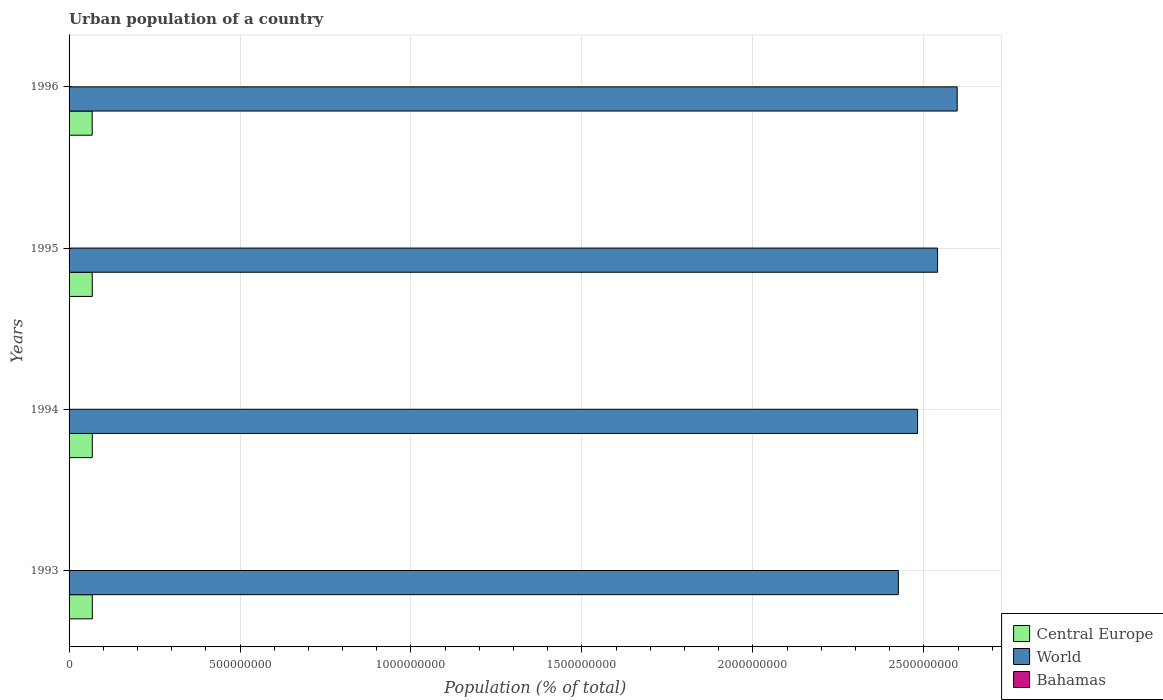How many different coloured bars are there?
Your response must be concise. 3. How many bars are there on the 4th tick from the top?
Provide a succinct answer. 3. How many bars are there on the 1st tick from the bottom?
Give a very brief answer. 3. In how many cases, is the number of bars for a given year not equal to the number of legend labels?
Your response must be concise. 0. What is the urban population in World in 1996?
Give a very brief answer. 2.60e+09. Across all years, what is the maximum urban population in World?
Ensure brevity in your answer.  2.60e+09. Across all years, what is the minimum urban population in Bahamas?
Give a very brief answer. 2.18e+05. In which year was the urban population in Central Europe maximum?
Keep it short and to the point. 1993. In which year was the urban population in Central Europe minimum?
Offer a terse response. 1996. What is the total urban population in World in the graph?
Your answer should be very brief. 1.00e+1. What is the difference between the urban population in Bahamas in 1994 and that in 1995?
Give a very brief answer. -4049. What is the difference between the urban population in Bahamas in 1993 and the urban population in Central Europe in 1995?
Offer a terse response. -6.76e+07. What is the average urban population in Central Europe per year?
Your answer should be very brief. 6.78e+07. In the year 1994, what is the difference between the urban population in World and urban population in Central Europe?
Offer a very short reply. 2.41e+09. What is the ratio of the urban population in Bahamas in 1993 to that in 1995?
Your answer should be compact. 0.96. Is the urban population in Central Europe in 1994 less than that in 1996?
Keep it short and to the point. No. Is the difference between the urban population in World in 1993 and 1994 greater than the difference between the urban population in Central Europe in 1993 and 1994?
Make the answer very short. No. What is the difference between the highest and the second highest urban population in Bahamas?
Make the answer very short. 3569. What is the difference between the highest and the lowest urban population in Bahamas?
Keep it short and to the point. 1.20e+04. What does the 1st bar from the top in 1996 represents?
Your response must be concise. Bahamas. What does the 1st bar from the bottom in 1994 represents?
Give a very brief answer. Central Europe. Is it the case that in every year, the sum of the urban population in World and urban population in Central Europe is greater than the urban population in Bahamas?
Give a very brief answer. Yes. How many bars are there?
Give a very brief answer. 12. Are all the bars in the graph horizontal?
Give a very brief answer. Yes. What is the difference between two consecutive major ticks on the X-axis?
Give a very brief answer. 5.00e+08. Does the graph contain any zero values?
Provide a short and direct response. No. Where does the legend appear in the graph?
Give a very brief answer. Bottom right. What is the title of the graph?
Ensure brevity in your answer.  Urban population of a country. Does "Czech Republic" appear as one of the legend labels in the graph?
Your answer should be very brief. No. What is the label or title of the X-axis?
Keep it short and to the point. Population (% of total). What is the label or title of the Y-axis?
Provide a succinct answer. Years. What is the Population (% of total) of Central Europe in 1993?
Your answer should be very brief. 6.80e+07. What is the Population (% of total) of World in 1993?
Offer a very short reply. 2.43e+09. What is the Population (% of total) in Bahamas in 1993?
Ensure brevity in your answer.  2.18e+05. What is the Population (% of total) in Central Europe in 1994?
Offer a very short reply. 6.79e+07. What is the Population (% of total) of World in 1994?
Give a very brief answer. 2.48e+09. What is the Population (% of total) of Bahamas in 1994?
Offer a very short reply. 2.23e+05. What is the Population (% of total) of Central Europe in 1995?
Your answer should be compact. 6.78e+07. What is the Population (% of total) of World in 1995?
Offer a very short reply. 2.54e+09. What is the Population (% of total) in Bahamas in 1995?
Your answer should be very brief. 2.27e+05. What is the Population (% of total) of Central Europe in 1996?
Keep it short and to the point. 6.76e+07. What is the Population (% of total) of World in 1996?
Your response must be concise. 2.60e+09. What is the Population (% of total) of Bahamas in 1996?
Provide a succinct answer. 2.30e+05. Across all years, what is the maximum Population (% of total) in Central Europe?
Your answer should be very brief. 6.80e+07. Across all years, what is the maximum Population (% of total) of World?
Offer a very short reply. 2.60e+09. Across all years, what is the maximum Population (% of total) in Bahamas?
Your answer should be very brief. 2.30e+05. Across all years, what is the minimum Population (% of total) in Central Europe?
Give a very brief answer. 6.76e+07. Across all years, what is the minimum Population (% of total) in World?
Ensure brevity in your answer.  2.43e+09. Across all years, what is the minimum Population (% of total) in Bahamas?
Your response must be concise. 2.18e+05. What is the total Population (% of total) of Central Europe in the graph?
Your answer should be very brief. 2.71e+08. What is the total Population (% of total) of World in the graph?
Provide a short and direct response. 1.00e+1. What is the total Population (% of total) in Bahamas in the graph?
Your answer should be compact. 8.98e+05. What is the difference between the Population (% of total) of Central Europe in 1993 and that in 1994?
Offer a terse response. 6.94e+04. What is the difference between the Population (% of total) in World in 1993 and that in 1994?
Provide a succinct answer. -5.63e+07. What is the difference between the Population (% of total) of Bahamas in 1993 and that in 1994?
Ensure brevity in your answer.  -4427. What is the difference between the Population (% of total) in Central Europe in 1993 and that in 1995?
Your response must be concise. 1.74e+05. What is the difference between the Population (% of total) in World in 1993 and that in 1995?
Ensure brevity in your answer.  -1.15e+08. What is the difference between the Population (% of total) of Bahamas in 1993 and that in 1995?
Offer a very short reply. -8476. What is the difference between the Population (% of total) in Central Europe in 1993 and that in 1996?
Your answer should be compact. 4.12e+05. What is the difference between the Population (% of total) in World in 1993 and that in 1996?
Provide a succinct answer. -1.72e+08. What is the difference between the Population (% of total) of Bahamas in 1993 and that in 1996?
Offer a very short reply. -1.20e+04. What is the difference between the Population (% of total) of Central Europe in 1994 and that in 1995?
Give a very brief answer. 1.04e+05. What is the difference between the Population (% of total) in World in 1994 and that in 1995?
Provide a succinct answer. -5.84e+07. What is the difference between the Population (% of total) in Bahamas in 1994 and that in 1995?
Your response must be concise. -4049. What is the difference between the Population (% of total) in Central Europe in 1994 and that in 1996?
Offer a very short reply. 3.42e+05. What is the difference between the Population (% of total) of World in 1994 and that in 1996?
Provide a succinct answer. -1.16e+08. What is the difference between the Population (% of total) of Bahamas in 1994 and that in 1996?
Ensure brevity in your answer.  -7618. What is the difference between the Population (% of total) of Central Europe in 1995 and that in 1996?
Your answer should be compact. 2.38e+05. What is the difference between the Population (% of total) in World in 1995 and that in 1996?
Ensure brevity in your answer.  -5.74e+07. What is the difference between the Population (% of total) of Bahamas in 1995 and that in 1996?
Offer a very short reply. -3569. What is the difference between the Population (% of total) of Central Europe in 1993 and the Population (% of total) of World in 1994?
Keep it short and to the point. -2.41e+09. What is the difference between the Population (% of total) in Central Europe in 1993 and the Population (% of total) in Bahamas in 1994?
Keep it short and to the point. 6.78e+07. What is the difference between the Population (% of total) in World in 1993 and the Population (% of total) in Bahamas in 1994?
Your response must be concise. 2.43e+09. What is the difference between the Population (% of total) of Central Europe in 1993 and the Population (% of total) of World in 1995?
Make the answer very short. -2.47e+09. What is the difference between the Population (% of total) in Central Europe in 1993 and the Population (% of total) in Bahamas in 1995?
Ensure brevity in your answer.  6.78e+07. What is the difference between the Population (% of total) in World in 1993 and the Population (% of total) in Bahamas in 1995?
Your answer should be compact. 2.43e+09. What is the difference between the Population (% of total) of Central Europe in 1993 and the Population (% of total) of World in 1996?
Your answer should be compact. -2.53e+09. What is the difference between the Population (% of total) of Central Europe in 1993 and the Population (% of total) of Bahamas in 1996?
Your response must be concise. 6.78e+07. What is the difference between the Population (% of total) in World in 1993 and the Population (% of total) in Bahamas in 1996?
Make the answer very short. 2.43e+09. What is the difference between the Population (% of total) in Central Europe in 1994 and the Population (% of total) in World in 1995?
Keep it short and to the point. -2.47e+09. What is the difference between the Population (% of total) of Central Europe in 1994 and the Population (% of total) of Bahamas in 1995?
Your response must be concise. 6.77e+07. What is the difference between the Population (% of total) of World in 1994 and the Population (% of total) of Bahamas in 1995?
Ensure brevity in your answer.  2.48e+09. What is the difference between the Population (% of total) of Central Europe in 1994 and the Population (% of total) of World in 1996?
Your answer should be compact. -2.53e+09. What is the difference between the Population (% of total) in Central Europe in 1994 and the Population (% of total) in Bahamas in 1996?
Make the answer very short. 6.77e+07. What is the difference between the Population (% of total) of World in 1994 and the Population (% of total) of Bahamas in 1996?
Keep it short and to the point. 2.48e+09. What is the difference between the Population (% of total) in Central Europe in 1995 and the Population (% of total) in World in 1996?
Offer a terse response. -2.53e+09. What is the difference between the Population (% of total) of Central Europe in 1995 and the Population (% of total) of Bahamas in 1996?
Make the answer very short. 6.76e+07. What is the difference between the Population (% of total) of World in 1995 and the Population (% of total) of Bahamas in 1996?
Make the answer very short. 2.54e+09. What is the average Population (% of total) of Central Europe per year?
Provide a succinct answer. 6.78e+07. What is the average Population (% of total) of World per year?
Provide a succinct answer. 2.51e+09. What is the average Population (% of total) of Bahamas per year?
Your response must be concise. 2.25e+05. In the year 1993, what is the difference between the Population (% of total) of Central Europe and Population (% of total) of World?
Ensure brevity in your answer.  -2.36e+09. In the year 1993, what is the difference between the Population (% of total) in Central Europe and Population (% of total) in Bahamas?
Offer a terse response. 6.78e+07. In the year 1993, what is the difference between the Population (% of total) in World and Population (% of total) in Bahamas?
Provide a succinct answer. 2.43e+09. In the year 1994, what is the difference between the Population (% of total) of Central Europe and Population (% of total) of World?
Your answer should be compact. -2.41e+09. In the year 1994, what is the difference between the Population (% of total) of Central Europe and Population (% of total) of Bahamas?
Your answer should be very brief. 6.77e+07. In the year 1994, what is the difference between the Population (% of total) of World and Population (% of total) of Bahamas?
Keep it short and to the point. 2.48e+09. In the year 1995, what is the difference between the Population (% of total) in Central Europe and Population (% of total) in World?
Offer a terse response. -2.47e+09. In the year 1995, what is the difference between the Population (% of total) in Central Europe and Population (% of total) in Bahamas?
Give a very brief answer. 6.76e+07. In the year 1995, what is the difference between the Population (% of total) of World and Population (% of total) of Bahamas?
Your answer should be compact. 2.54e+09. In the year 1996, what is the difference between the Population (% of total) in Central Europe and Population (% of total) in World?
Ensure brevity in your answer.  -2.53e+09. In the year 1996, what is the difference between the Population (% of total) of Central Europe and Population (% of total) of Bahamas?
Your answer should be very brief. 6.74e+07. In the year 1996, what is the difference between the Population (% of total) of World and Population (% of total) of Bahamas?
Provide a succinct answer. 2.60e+09. What is the ratio of the Population (% of total) of Central Europe in 1993 to that in 1994?
Your answer should be very brief. 1. What is the ratio of the Population (% of total) of World in 1993 to that in 1994?
Ensure brevity in your answer.  0.98. What is the ratio of the Population (% of total) in Bahamas in 1993 to that in 1994?
Offer a terse response. 0.98. What is the ratio of the Population (% of total) in Central Europe in 1993 to that in 1995?
Offer a terse response. 1. What is the ratio of the Population (% of total) of World in 1993 to that in 1995?
Provide a short and direct response. 0.95. What is the ratio of the Population (% of total) of Bahamas in 1993 to that in 1995?
Provide a succinct answer. 0.96. What is the ratio of the Population (% of total) in Central Europe in 1993 to that in 1996?
Give a very brief answer. 1.01. What is the ratio of the Population (% of total) of World in 1993 to that in 1996?
Keep it short and to the point. 0.93. What is the ratio of the Population (% of total) of Bahamas in 1993 to that in 1996?
Offer a very short reply. 0.95. What is the ratio of the Population (% of total) in World in 1994 to that in 1995?
Provide a succinct answer. 0.98. What is the ratio of the Population (% of total) in Bahamas in 1994 to that in 1995?
Give a very brief answer. 0.98. What is the ratio of the Population (% of total) of World in 1994 to that in 1996?
Give a very brief answer. 0.96. What is the ratio of the Population (% of total) in Bahamas in 1994 to that in 1996?
Ensure brevity in your answer.  0.97. What is the ratio of the Population (% of total) in World in 1995 to that in 1996?
Ensure brevity in your answer.  0.98. What is the ratio of the Population (% of total) of Bahamas in 1995 to that in 1996?
Provide a succinct answer. 0.98. What is the difference between the highest and the second highest Population (% of total) of Central Europe?
Provide a short and direct response. 6.94e+04. What is the difference between the highest and the second highest Population (% of total) in World?
Provide a succinct answer. 5.74e+07. What is the difference between the highest and the second highest Population (% of total) in Bahamas?
Give a very brief answer. 3569. What is the difference between the highest and the lowest Population (% of total) of Central Europe?
Offer a terse response. 4.12e+05. What is the difference between the highest and the lowest Population (% of total) in World?
Provide a succinct answer. 1.72e+08. What is the difference between the highest and the lowest Population (% of total) of Bahamas?
Make the answer very short. 1.20e+04. 